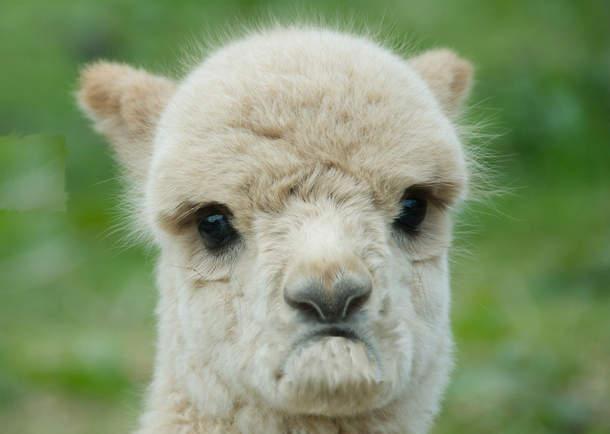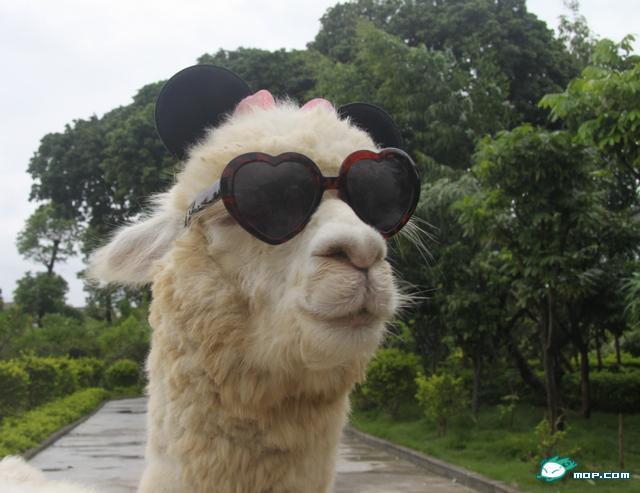The first image is the image on the left, the second image is the image on the right. Given the left and right images, does the statement "In the image on the right, the llama's eyes are obscured." hold true? Answer yes or no. Yes. The first image is the image on the left, the second image is the image on the right. Analyze the images presented: Is the assertion "Each image features one llama in the foreground, and the righthand llama looks at the camera with a toothy smile." valid? Answer yes or no. No. 